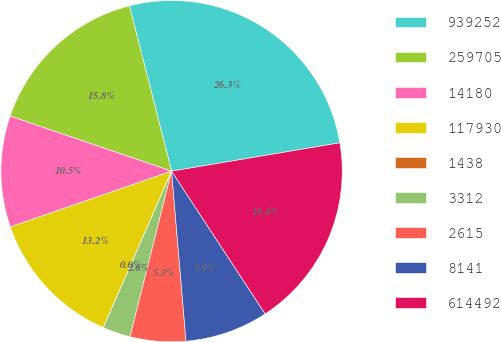Convert chart. <chart><loc_0><loc_0><loc_500><loc_500><pie_chart><fcel>939252<fcel>259705<fcel>14180<fcel>117930<fcel>1438<fcel>3312<fcel>2615<fcel>8141<fcel>614492<nl><fcel>26.32%<fcel>15.79%<fcel>10.53%<fcel>13.16%<fcel>0.0%<fcel>2.63%<fcel>5.26%<fcel>7.89%<fcel>18.42%<nl></chart> 